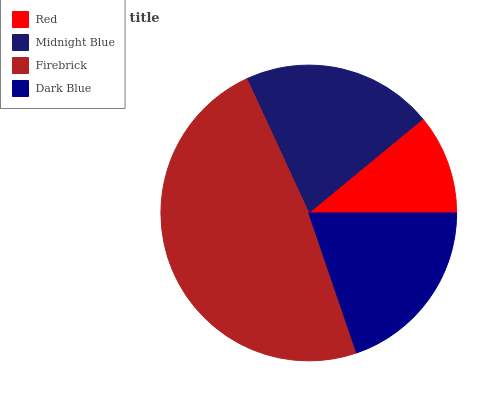Is Red the minimum?
Answer yes or no. Yes. Is Firebrick the maximum?
Answer yes or no. Yes. Is Midnight Blue the minimum?
Answer yes or no. No. Is Midnight Blue the maximum?
Answer yes or no. No. Is Midnight Blue greater than Red?
Answer yes or no. Yes. Is Red less than Midnight Blue?
Answer yes or no. Yes. Is Red greater than Midnight Blue?
Answer yes or no. No. Is Midnight Blue less than Red?
Answer yes or no. No. Is Midnight Blue the high median?
Answer yes or no. Yes. Is Dark Blue the low median?
Answer yes or no. Yes. Is Red the high median?
Answer yes or no. No. Is Firebrick the low median?
Answer yes or no. No. 